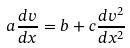<formula> <loc_0><loc_0><loc_500><loc_500>a \frac { d v } { d x } = b + c \frac { d v ^ { 2 } } { d x ^ { 2 } }</formula> 